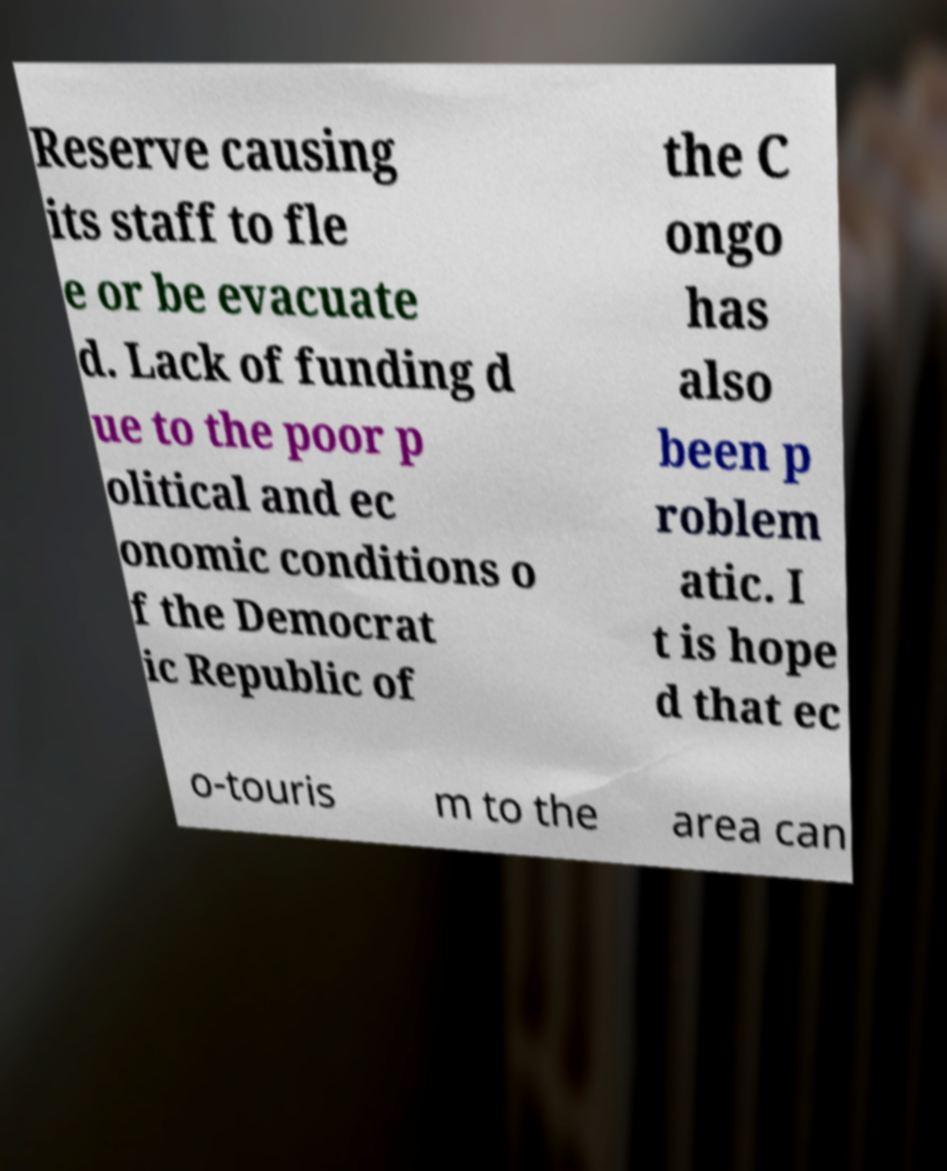I need the written content from this picture converted into text. Can you do that? Reserve causing its staff to fle e or be evacuate d. Lack of funding d ue to the poor p olitical and ec onomic conditions o f the Democrat ic Republic of the C ongo has also been p roblem atic. I t is hope d that ec o-touris m to the area can 